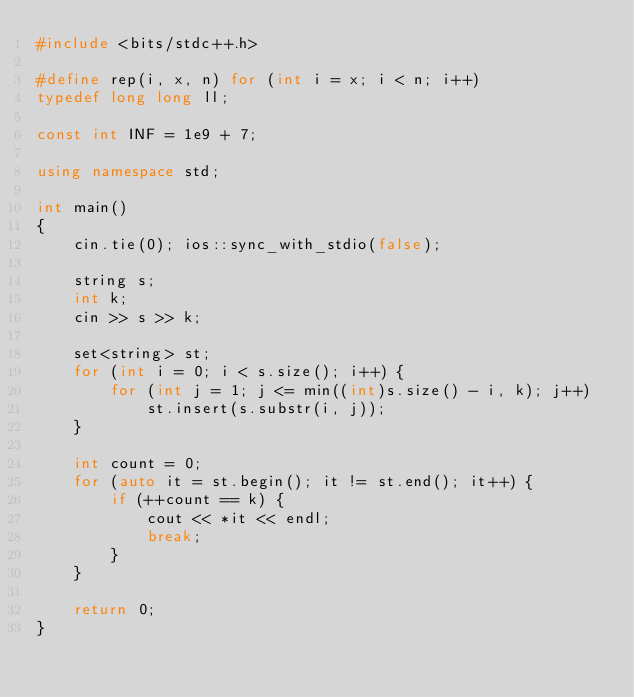<code> <loc_0><loc_0><loc_500><loc_500><_C++_>#include <bits/stdc++.h>

#define rep(i, x, n) for (int i = x; i < n; i++)
typedef long long ll;

const int INF = 1e9 + 7;

using namespace std;

int main()
{
	cin.tie(0); ios::sync_with_stdio(false);

	string s;
	int k;
	cin >> s >> k;

	set<string> st;
	for (int i = 0; i < s.size(); i++) {
		for (int j = 1; j <= min((int)s.size() - i, k); j++)
			st.insert(s.substr(i, j));
	}

	int count = 0;
	for (auto it = st.begin(); it != st.end(); it++) {
		if (++count == k) {
			cout << *it << endl;
			break;
		}
	}

	return 0;
}</code> 